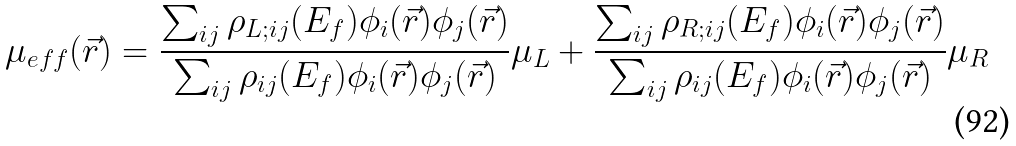Convert formula to latex. <formula><loc_0><loc_0><loc_500><loc_500>\mu _ { e f f } ( \vec { r } ) = \frac { \sum _ { i j } \rho _ { L ; i j } ( E _ { f } ) \phi _ { i } ( \vec { r } ) \phi _ { j } ( \vec { r } ) } { \sum _ { i j } \rho _ { i j } ( E _ { f } ) \phi _ { i } ( \vec { r } ) \phi _ { j } ( \vec { r } ) } \mu _ { L } + \frac { \sum _ { i j } \rho _ { R ; i j } ( E _ { f } ) \phi _ { i } ( \vec { r } ) \phi _ { j } ( \vec { r } ) } { \sum _ { i j } \rho _ { i j } ( E _ { f } ) \phi _ { i } ( \vec { r } ) \phi _ { j } ( \vec { r } ) } \mu _ { R }</formula> 